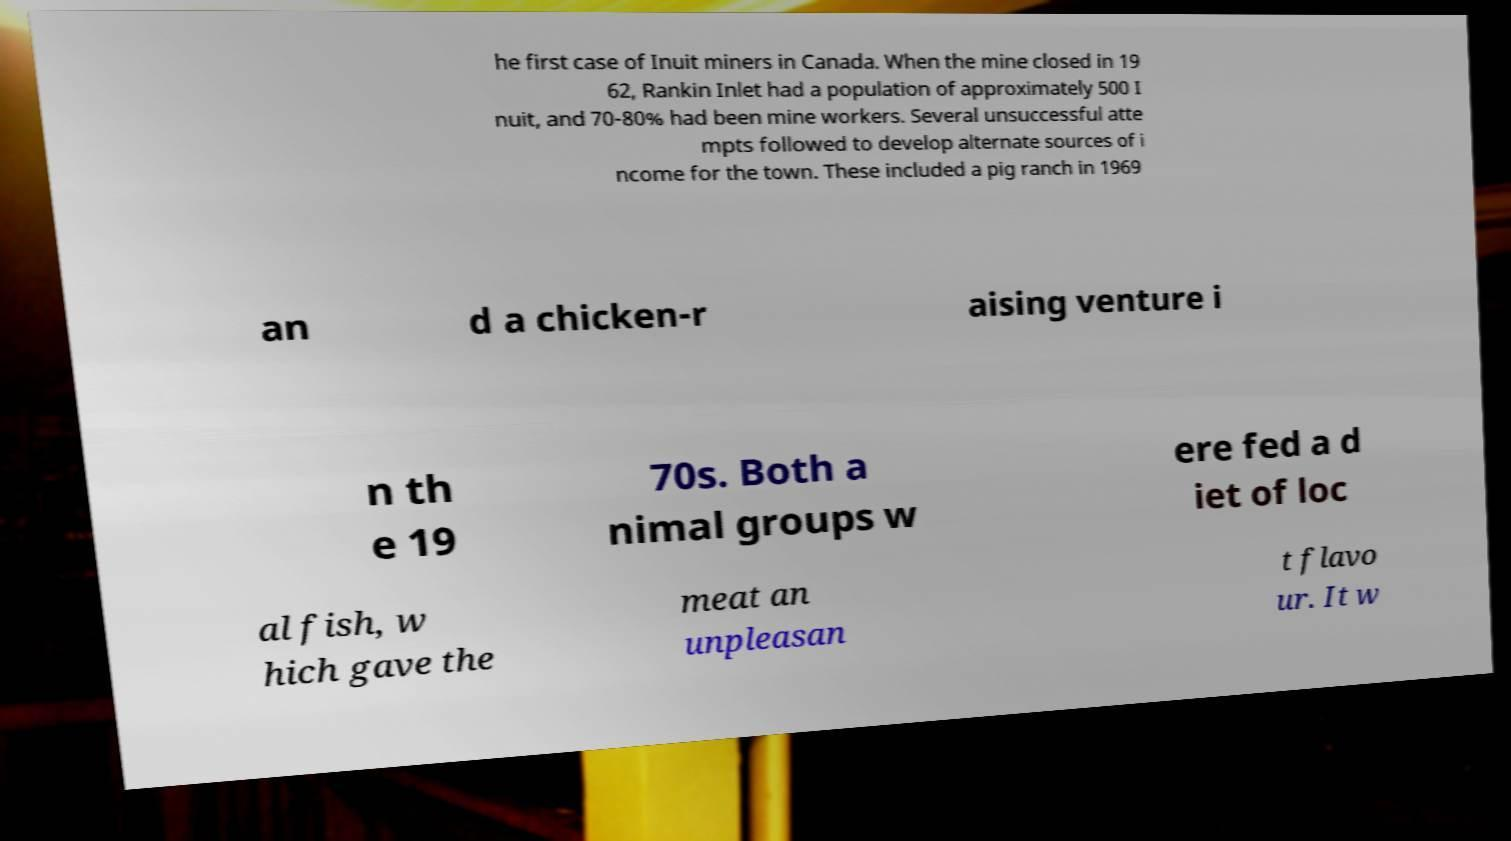Can you read and provide the text displayed in the image?This photo seems to have some interesting text. Can you extract and type it out for me? he first case of Inuit miners in Canada. When the mine closed in 19 62, Rankin Inlet had a population of approximately 500 I nuit, and 70-80% had been mine workers. Several unsuccessful atte mpts followed to develop alternate sources of i ncome for the town. These included a pig ranch in 1969 an d a chicken-r aising venture i n th e 19 70s. Both a nimal groups w ere fed a d iet of loc al fish, w hich gave the meat an unpleasan t flavo ur. It w 